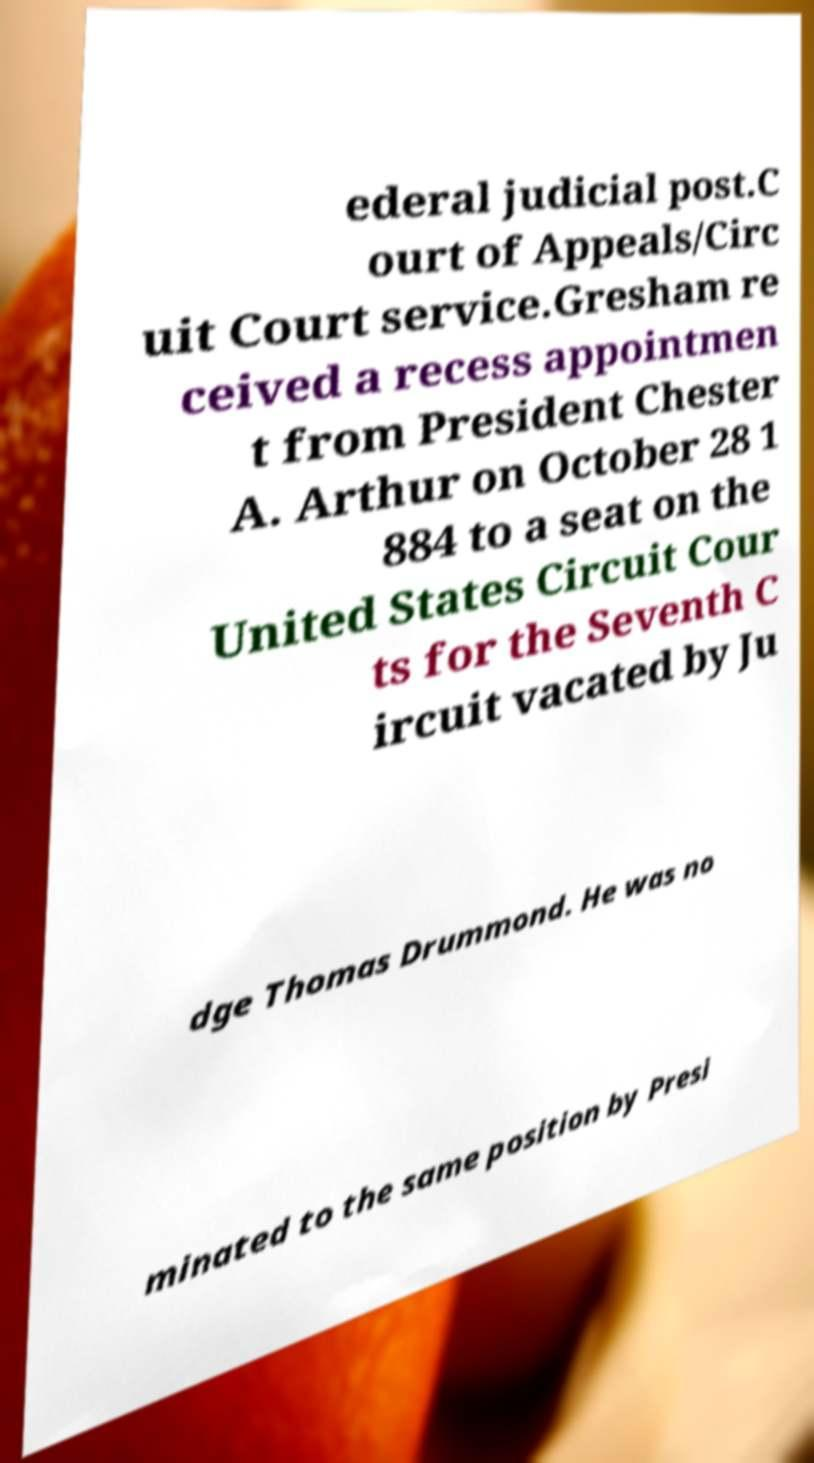There's text embedded in this image that I need extracted. Can you transcribe it verbatim? ederal judicial post.C ourt of Appeals/Circ uit Court service.Gresham re ceived a recess appointmen t from President Chester A. Arthur on October 28 1 884 to a seat on the United States Circuit Cour ts for the Seventh C ircuit vacated by Ju dge Thomas Drummond. He was no minated to the same position by Presi 